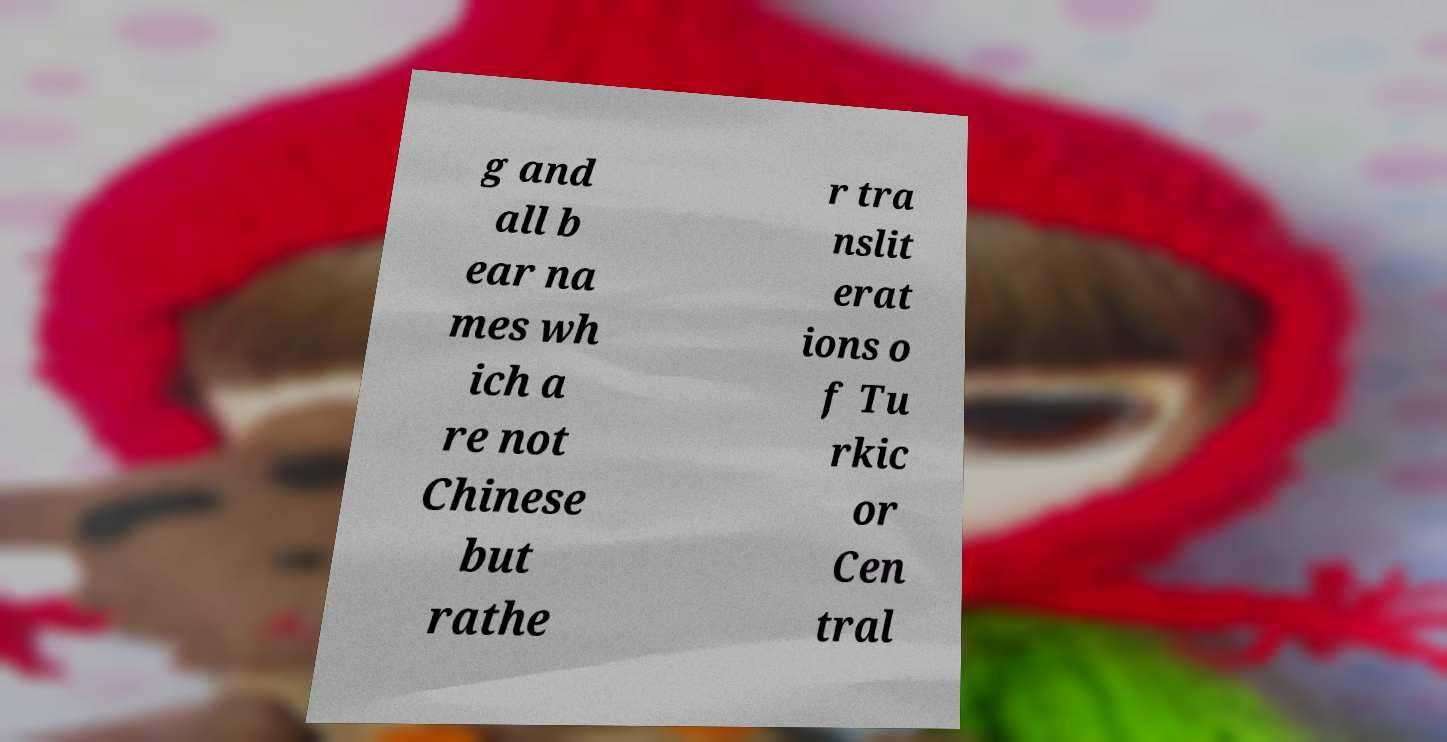For documentation purposes, I need the text within this image transcribed. Could you provide that? g and all b ear na mes wh ich a re not Chinese but rathe r tra nslit erat ions o f Tu rkic or Cen tral 